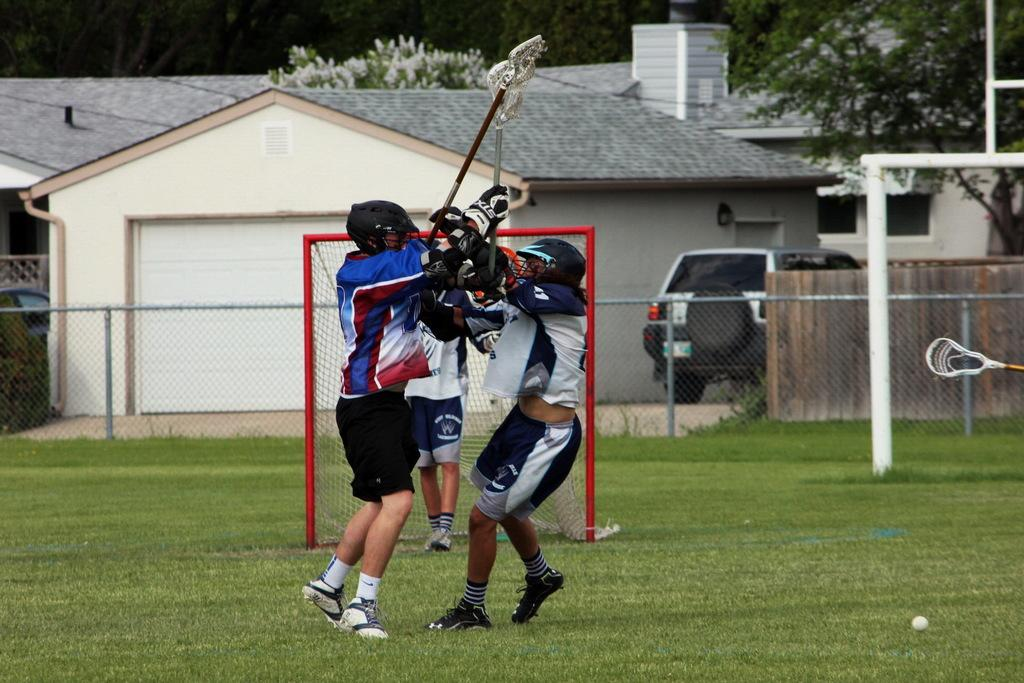What are the persons in the image doing? The persons in the image are standing on the ground and holding bats in their hands. What can be seen in the background of the image? In the background of the image, there is a fence, motor vehicles, buildings, and trees. What type of skin condition can be seen on the persons in the image? There is no mention of skin conditions in the image, so it cannot be determined from the image. 